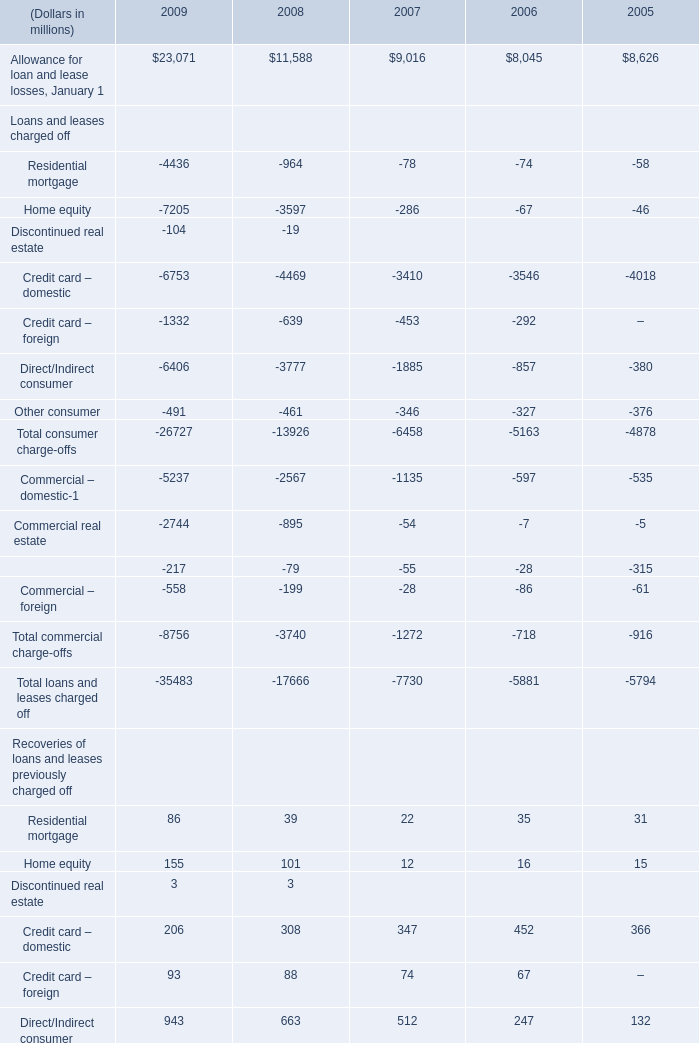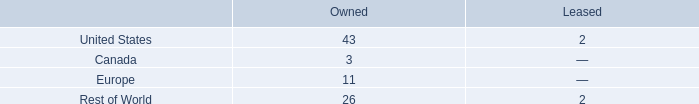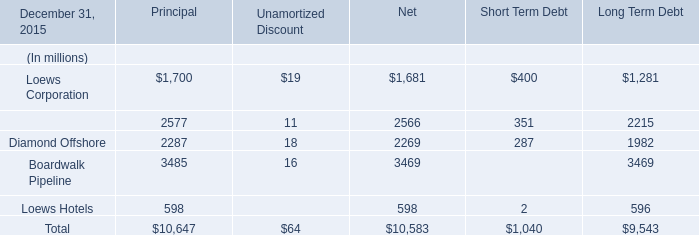what portion of the company owned facilities are located in europe? 
Computations: (11 / 83)
Answer: 0.13253. What is the total amount of Allowance for loan and lease losses, January 1 of 2008, Boardwalk Pipeline of Long Term Debt, and Allowance for loan and lease losses, January 1 of 2009 ? 
Computations: ((11588.0 + 3469.0) + 23071.0)
Answer: 38128.0. 